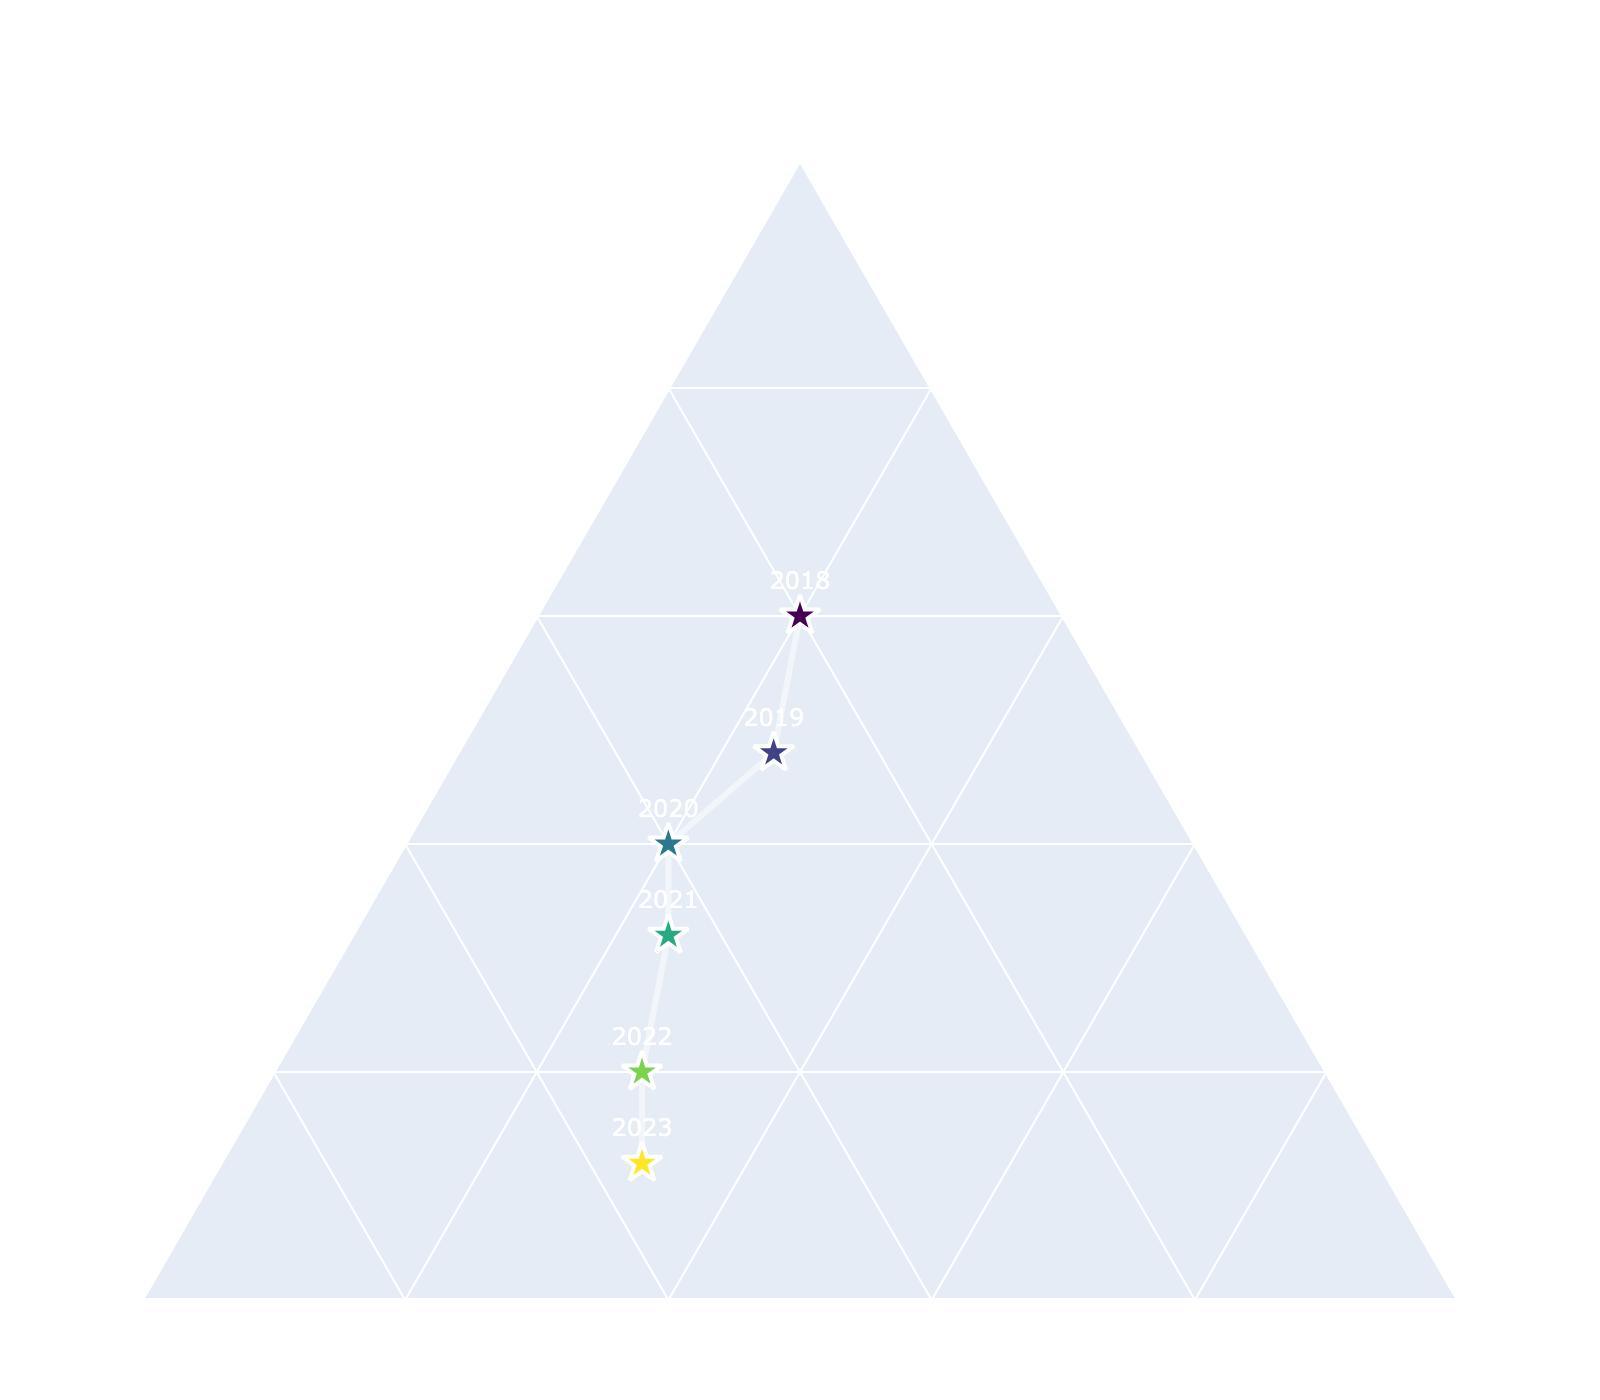What is the title of the figure? The title of the figure is displayed prominently at the top.
Answer: "Pakistan's Export Portfolio to Germany" How many data points are there in the figure? Each year from 2018 to 2023 is represented by a data point; thus, there are 6 data points.
Answer: 6 What was the percentage of Textiles in 2020? For 2020, the Textiles composition is marked along the 'Textiles' axis. In the data, Textiles for 2020 is 60%.
Answer: 60% Which export category has increased the most from 2018 to 2023? By observing the trends over the years for each category - Textiles, Agricultural Products, and Industrial Goods - it is evident from the plot that Agricultural Products have shown the most increase.
Answer: Agricultural Products In which year did Industrial Goods have the highest share in exports? The highest proportion of Industrial Goods over the years is shown by the vertical position on the 'Industrial Goods' axis. This maximum occurs in 2023 where Industrial Goods is 18%.
Answer: 2023 What is the percentage change in Textiles share from 2018 to 2023? Compare Textiles' share in 2018 (65%) to 2023 (53%). The change is 65% - 53% = 12%.
Answer: 12% What's the average share of Agricultural Products over the given years? Sum the Agricultural Products percentages (20 + 22 + 25 + 26 + 28 + 29) and divide by 6 for the average. (150 / 6 = 25%)
Answer: 25% Which year had the most balanced mix of all three categories? The most balanced mix is where points are closest to the center of the ternary plot. 2023 shows the most balanced distribution.
Answer: 2023 How does the share of Industrial Goods in 2019 compare to 2021? By comparing Industrial Goods share in 2019 (16%) and 2021 (16%), the shares are equal.
Answer: Equal What trend can we observe in the composition of Textiles over the years? Textiles share shows a decreasing trend from 65% in 2018 to 53% in 2023.
Answer: Decreasing 